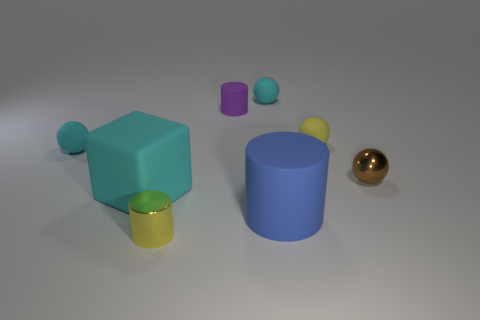Is there a tiny cyan ball that is in front of the cyan thing that is in front of the brown metallic sphere?
Keep it short and to the point. No. What color is the metallic cylinder that is the same size as the yellow ball?
Provide a succinct answer. Yellow. What number of objects are either brown rubber spheres or small balls?
Give a very brief answer. 4. How big is the cyan thing behind the ball to the left of the small cyan ball behind the small yellow sphere?
Your response must be concise. Small. What number of tiny balls are the same color as the block?
Your answer should be compact. 2. How many tiny yellow spheres have the same material as the blue object?
Offer a very short reply. 1. How many objects are either large blue cylinders or cyan balls that are to the left of the large blue rubber cylinder?
Offer a terse response. 3. There is a ball that is behind the yellow thing behind the small matte sphere left of the small metallic cylinder; what is its color?
Provide a short and direct response. Cyan. What is the size of the yellow metallic thing in front of the big blue thing?
Make the answer very short. Small. How many tiny objects are either cyan rubber things or blocks?
Make the answer very short. 2. 